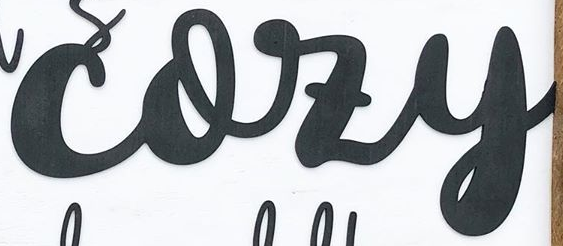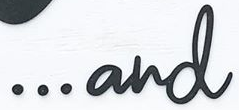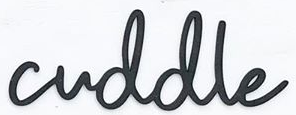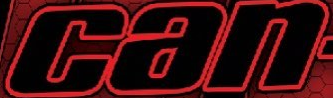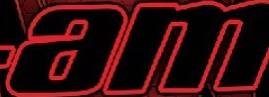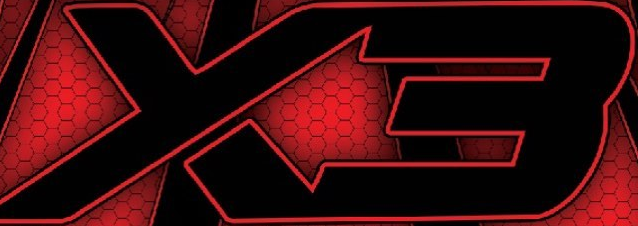What text appears in these images from left to right, separated by a semicolon? cozy; ...and; cuddle; can; am; X3 